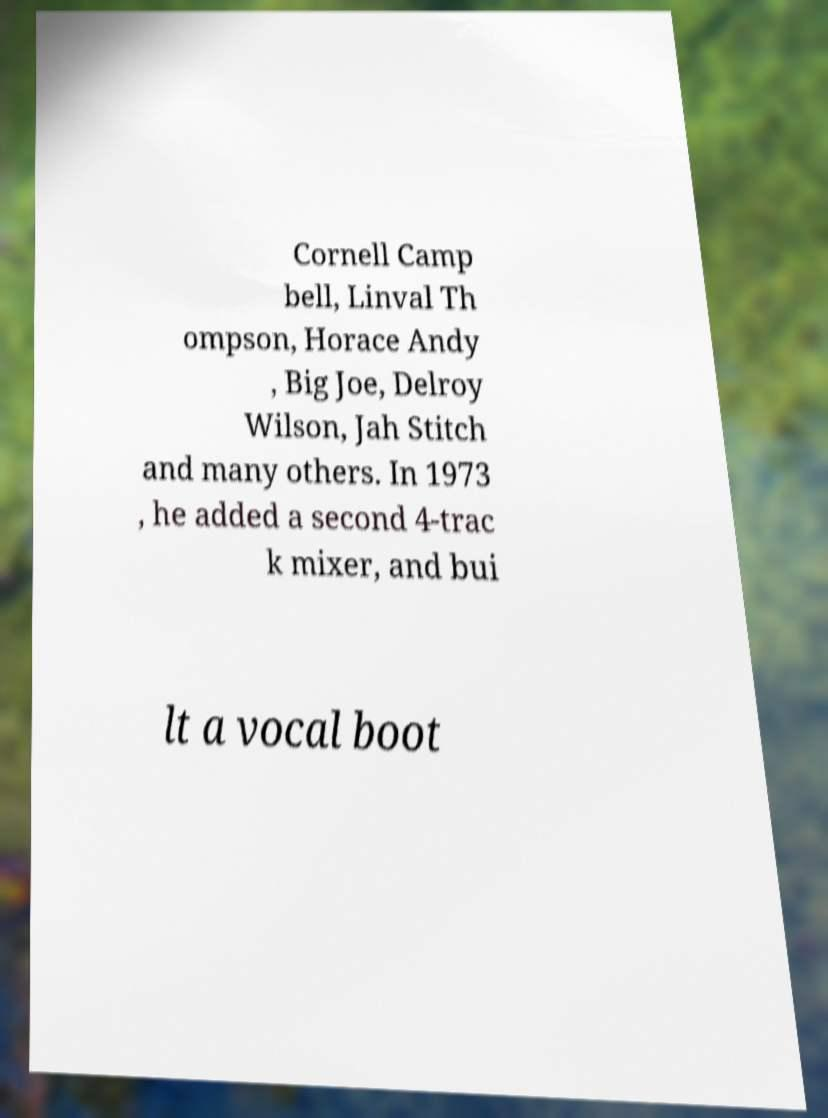Please read and relay the text visible in this image. What does it say? Cornell Camp bell, Linval Th ompson, Horace Andy , Big Joe, Delroy Wilson, Jah Stitch and many others. In 1973 , he added a second 4-trac k mixer, and bui lt a vocal boot 